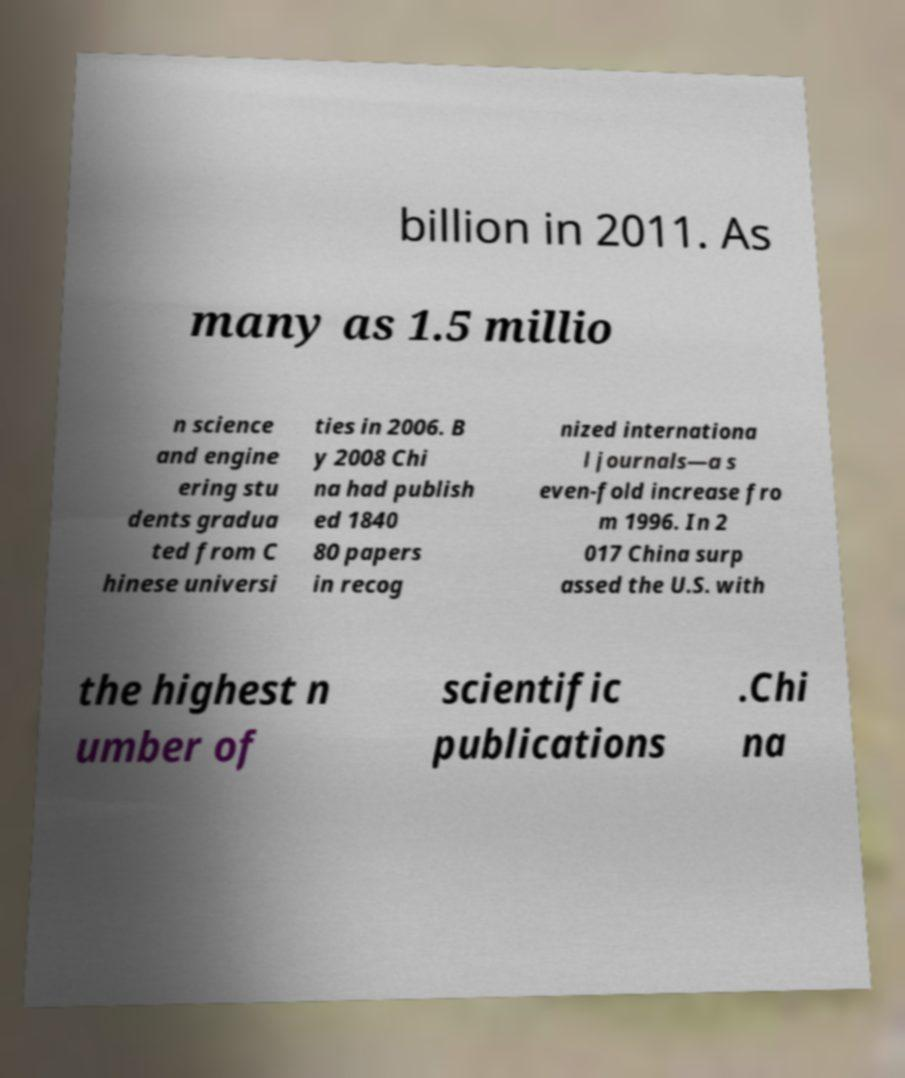Please read and relay the text visible in this image. What does it say? billion in 2011. As many as 1.5 millio n science and engine ering stu dents gradua ted from C hinese universi ties in 2006. B y 2008 Chi na had publish ed 1840 80 papers in recog nized internationa l journals—a s even-fold increase fro m 1996. In 2 017 China surp assed the U.S. with the highest n umber of scientific publications .Chi na 